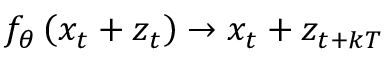<formula> <loc_0><loc_0><loc_500><loc_500>f _ { \theta } \left ( x _ { t } + z _ { t } \right ) \rightarrow x _ { t } + z _ { t + k T }</formula> 